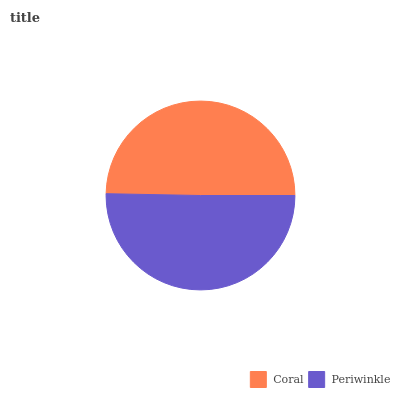Is Coral the minimum?
Answer yes or no. Yes. Is Periwinkle the maximum?
Answer yes or no. Yes. Is Periwinkle the minimum?
Answer yes or no. No. Is Periwinkle greater than Coral?
Answer yes or no. Yes. Is Coral less than Periwinkle?
Answer yes or no. Yes. Is Coral greater than Periwinkle?
Answer yes or no. No. Is Periwinkle less than Coral?
Answer yes or no. No. Is Periwinkle the high median?
Answer yes or no. Yes. Is Coral the low median?
Answer yes or no. Yes. Is Coral the high median?
Answer yes or no. No. Is Periwinkle the low median?
Answer yes or no. No. 